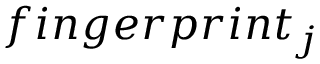<formula> <loc_0><loc_0><loc_500><loc_500>f i n g e r p r i n t _ { j }</formula> 